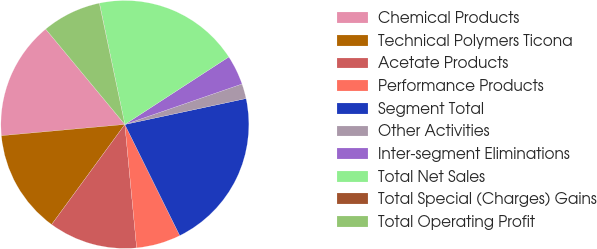Convert chart to OTSL. <chart><loc_0><loc_0><loc_500><loc_500><pie_chart><fcel>Chemical Products<fcel>Technical Polymers Ticona<fcel>Acetate Products<fcel>Performance Products<fcel>Segment Total<fcel>Other Activities<fcel>Inter-segment Eliminations<fcel>Total Net Sales<fcel>Total Special (Charges) Gains<fcel>Total Operating Profit<nl><fcel>15.42%<fcel>13.5%<fcel>11.57%<fcel>5.79%<fcel>21.05%<fcel>1.94%<fcel>3.87%<fcel>19.12%<fcel>0.02%<fcel>7.72%<nl></chart> 